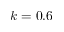Convert formula to latex. <formula><loc_0><loc_0><loc_500><loc_500>k = 0 . 6</formula> 